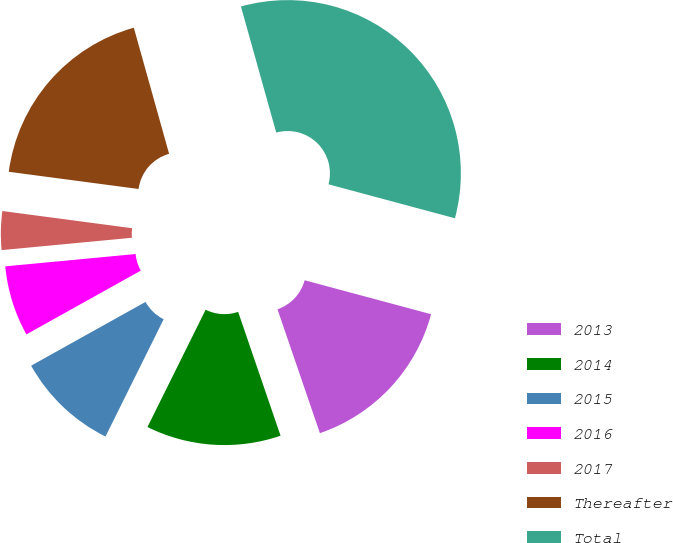Convert chart. <chart><loc_0><loc_0><loc_500><loc_500><pie_chart><fcel>2013<fcel>2014<fcel>2015<fcel>2016<fcel>2017<fcel>Thereafter<fcel>Total<nl><fcel>15.57%<fcel>12.58%<fcel>9.58%<fcel>6.59%<fcel>3.6%<fcel>18.56%<fcel>33.52%<nl></chart> 